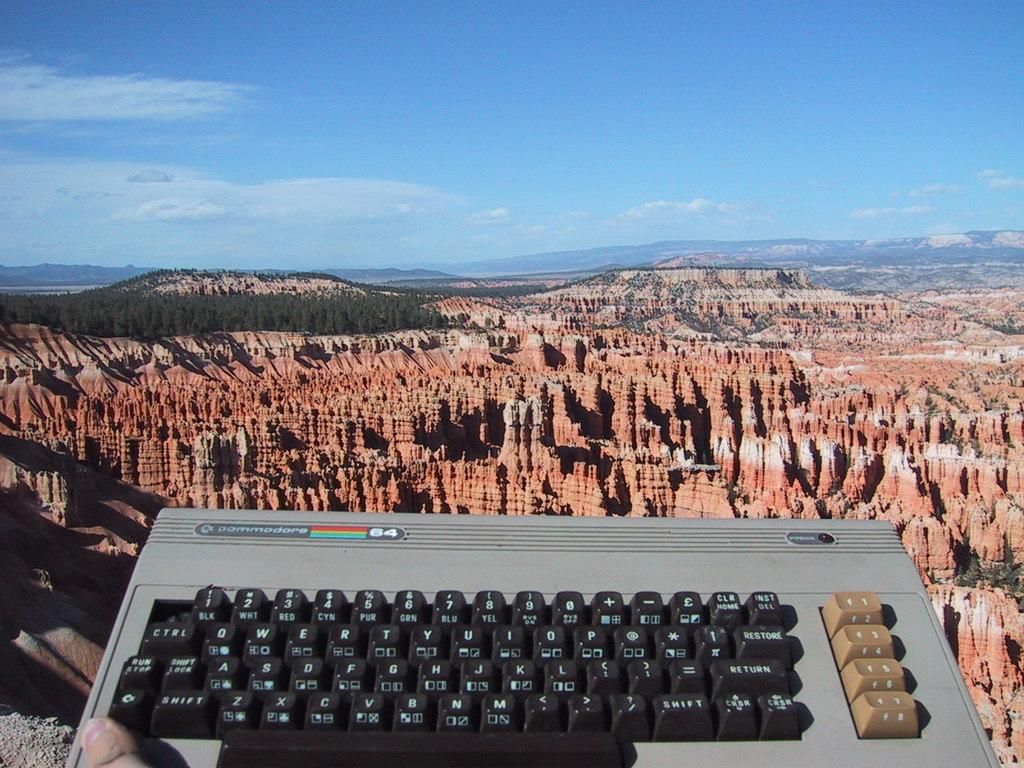Provide a one-sentence caption for the provided image. A Commodore keyboard is displayed in front of a large canyon. 